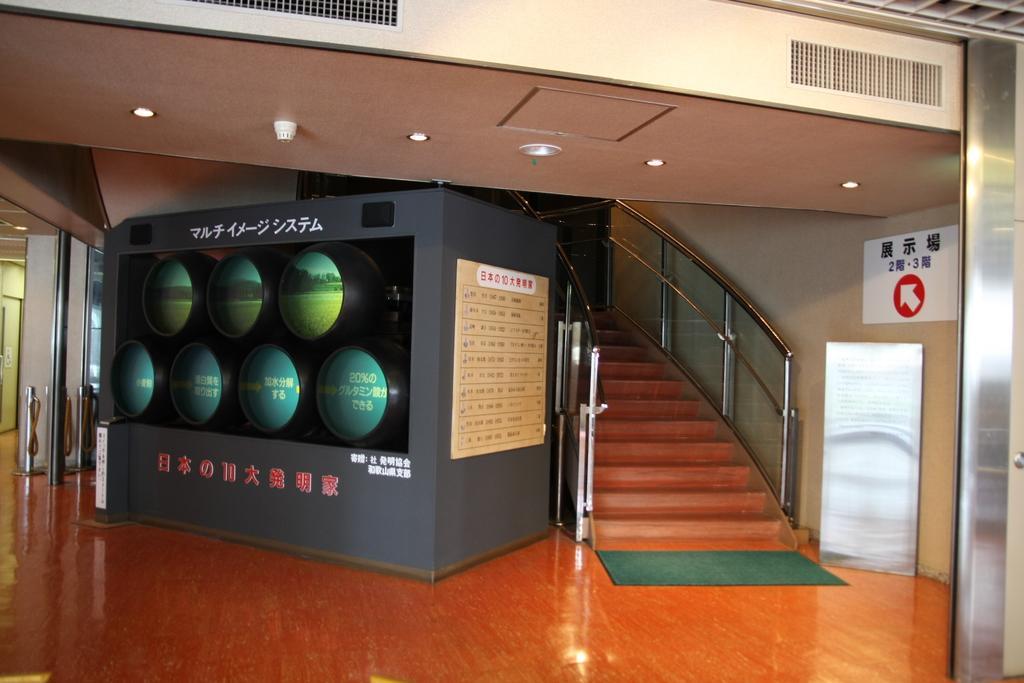Please provide a concise description of this image. In the image I can see a place in which there is a staircase, screen, mat and a board to the wall. 